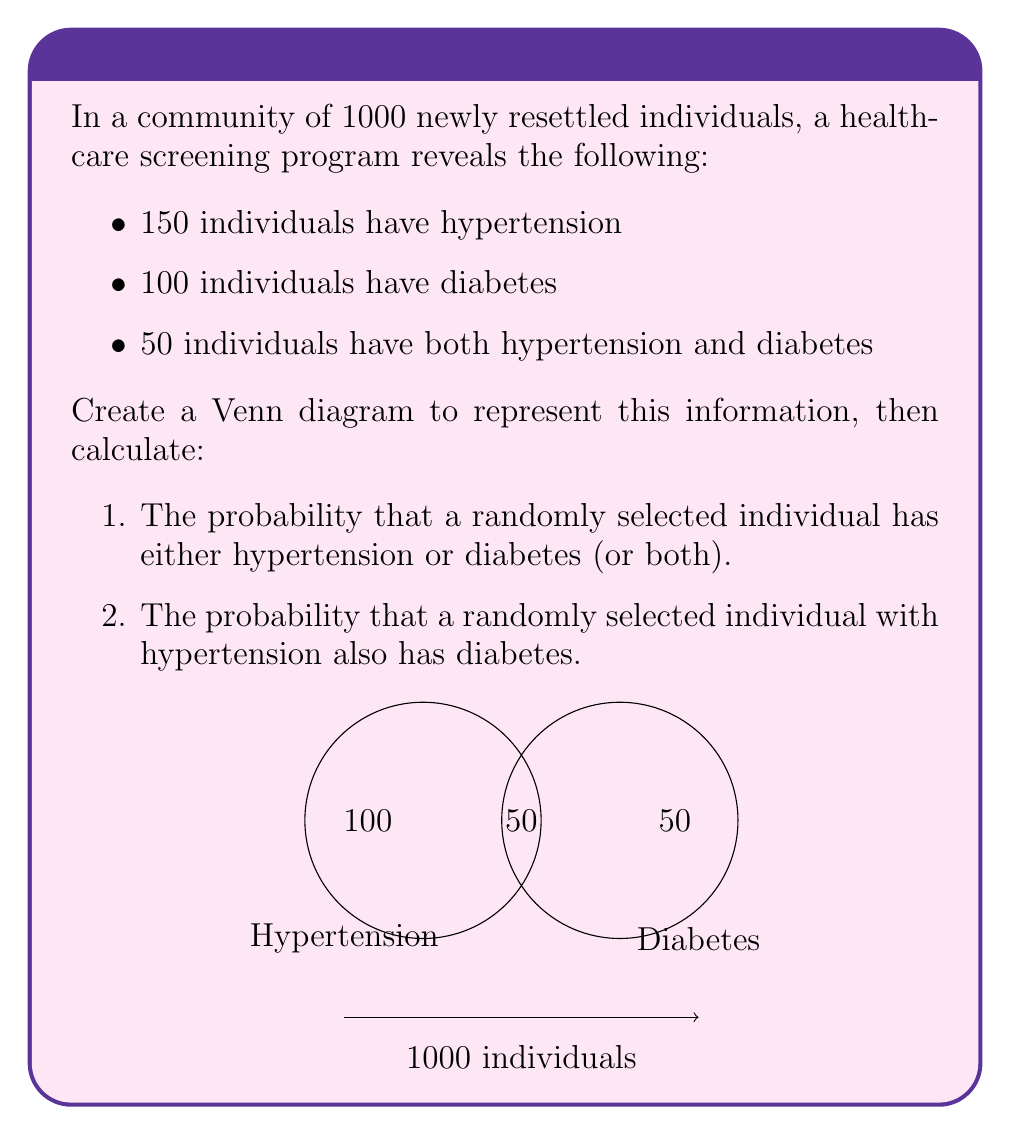Could you help me with this problem? Let's approach this step-by-step:

1. First, let's identify the key information:
   - Total population: 1000
   - Individuals with hypertension: 150
   - Individuals with diabetes: 100
   - Individuals with both: 50

2. To calculate the probability of having either hypertension or diabetes (or both), we need to find the total number of individuals with at least one of these conditions. We can use the addition principle of probability:

   $$ P(H \cup D) = P(H) + P(D) - P(H \cap D) $$

   Where $H$ represents hypertension and $D$ represents diabetes.

3. Number of individuals with at least one condition:
   $$ (150 - 50) + (100 - 50) + 50 = 100 + 50 + 50 = 200 $$

4. Probability of having either condition:
   $$ P(H \cup D) = \frac{200}{1000} = \frac{1}{5} = 0.2 $$

5. For the second part, we need to find the probability of having diabetes given that an individual has hypertension. This is a conditional probability:

   $$ P(D|H) = \frac{P(D \cap H)}{P(H)} $$

6. We know that:
   - $P(D \cap H) = \frac{50}{1000} = 0.05$ (probability of having both conditions)
   - $P(H) = \frac{150}{1000} = 0.15$ (probability of having hypertension)

7. Therefore:
   $$ P(D|H) = \frac{0.05}{0.15} = \frac{1}{3} \approx 0.333 $$
Answer: 1. $\frac{1}{5}$ or 0.2
2. $\frac{1}{3}$ or approximately 0.333 